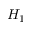Convert formula to latex. <formula><loc_0><loc_0><loc_500><loc_500>H _ { 1 }</formula> 